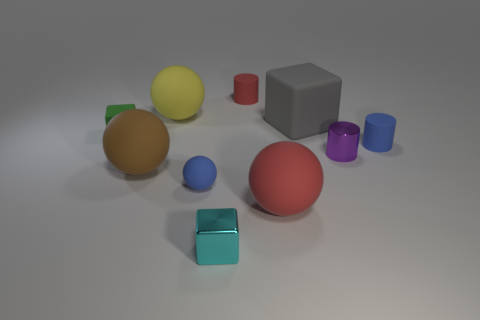There is a blue thing right of the big gray thing; does it have the same shape as the small red matte thing behind the red matte sphere?
Keep it short and to the point. Yes. Is there a large red ball that has the same material as the small blue sphere?
Give a very brief answer. Yes. Is the big sphere behind the purple metallic thing made of the same material as the small green cube?
Your answer should be very brief. Yes. Is the number of blue rubber things that are left of the shiny cylinder greater than the number of cyan blocks that are behind the big red sphere?
Keep it short and to the point. Yes. What color is the block that is the same size as the yellow rubber object?
Offer a terse response. Gray. There is a matte cylinder that is on the left side of the tiny blue matte cylinder; is its color the same as the big thing that is in front of the small rubber ball?
Offer a very short reply. Yes. There is a small cube to the right of the large brown matte thing; what is it made of?
Your answer should be compact. Metal. What is the color of the other cylinder that is made of the same material as the red cylinder?
Your answer should be compact. Blue. Does the green matte cube to the left of the purple thing have the same size as the blue rubber ball?
Your response must be concise. Yes. The object that is behind the green rubber object and to the right of the red ball has what shape?
Provide a short and direct response. Cube. 